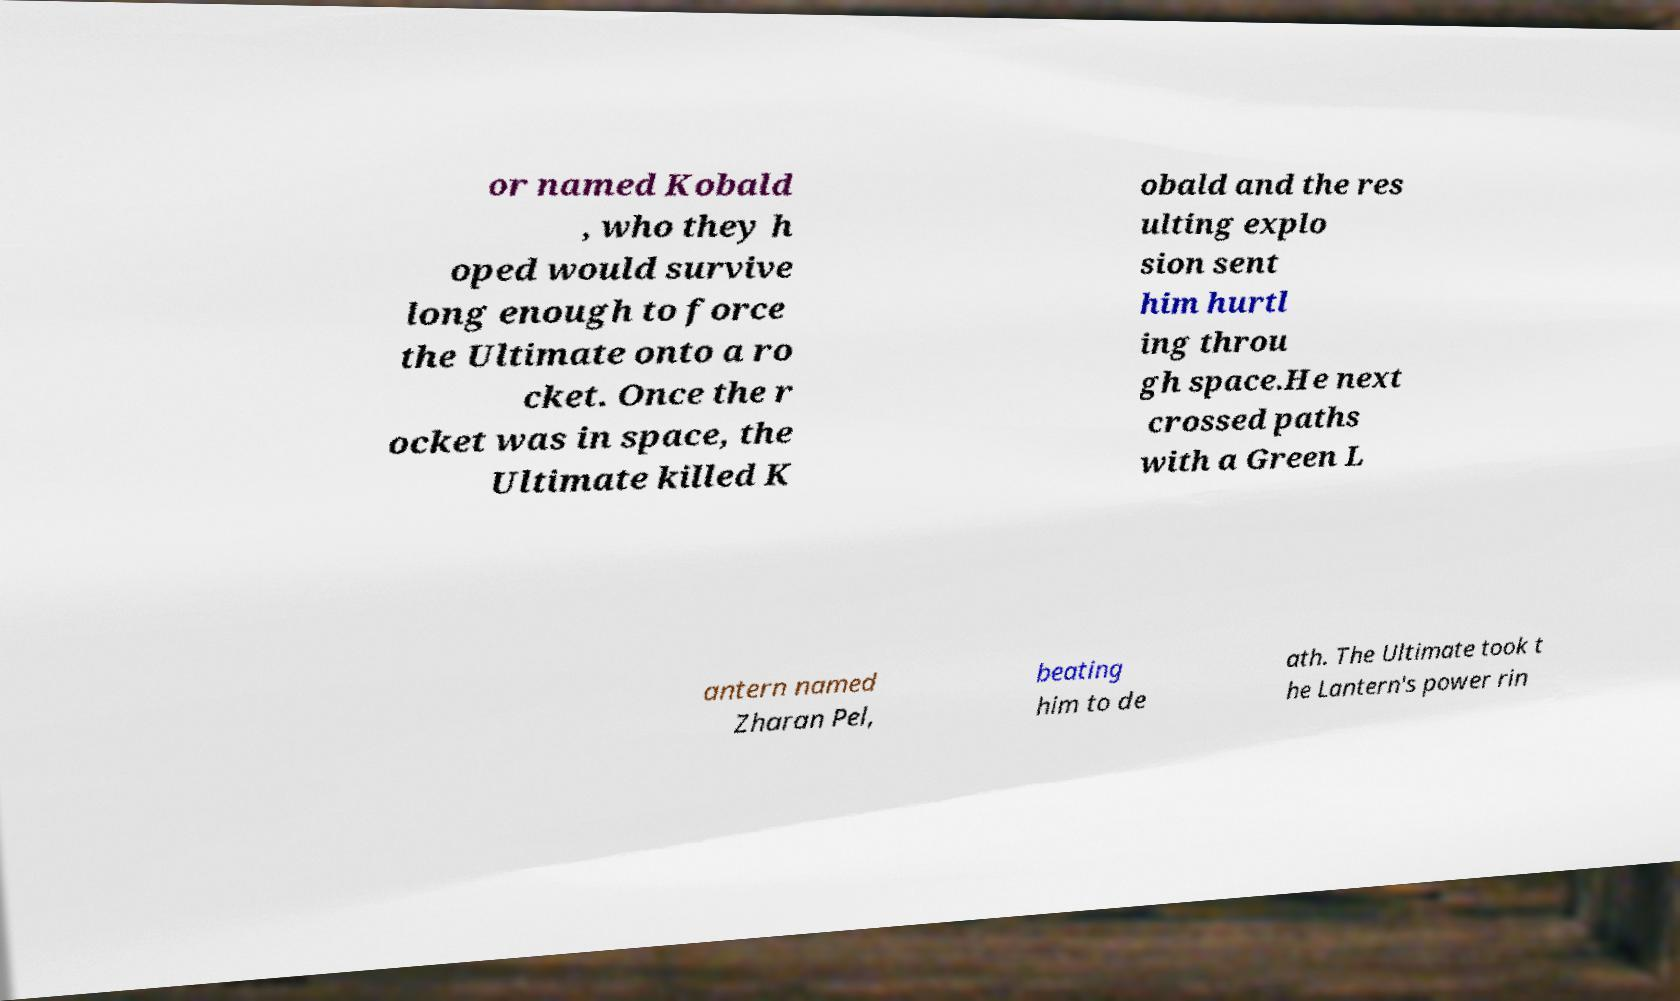There's text embedded in this image that I need extracted. Can you transcribe it verbatim? or named Kobald , who they h oped would survive long enough to force the Ultimate onto a ro cket. Once the r ocket was in space, the Ultimate killed K obald and the res ulting explo sion sent him hurtl ing throu gh space.He next crossed paths with a Green L antern named Zharan Pel, beating him to de ath. The Ultimate took t he Lantern's power rin 